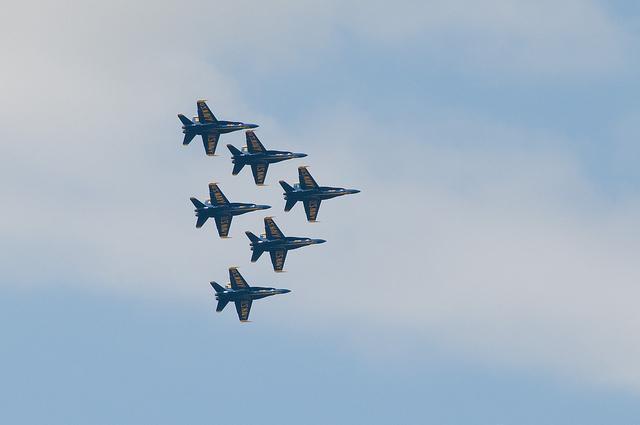How many planets are in the sky?
Give a very brief answer. 6. How many planes are there?
Give a very brief answer. 6. How many planes?
Give a very brief answer. 6. How many planes are in the air?
Give a very brief answer. 6. How many planes are in the image?
Give a very brief answer. 6. How many jets are there?
Give a very brief answer. 6. How many ducks have orange hats?
Give a very brief answer. 0. 